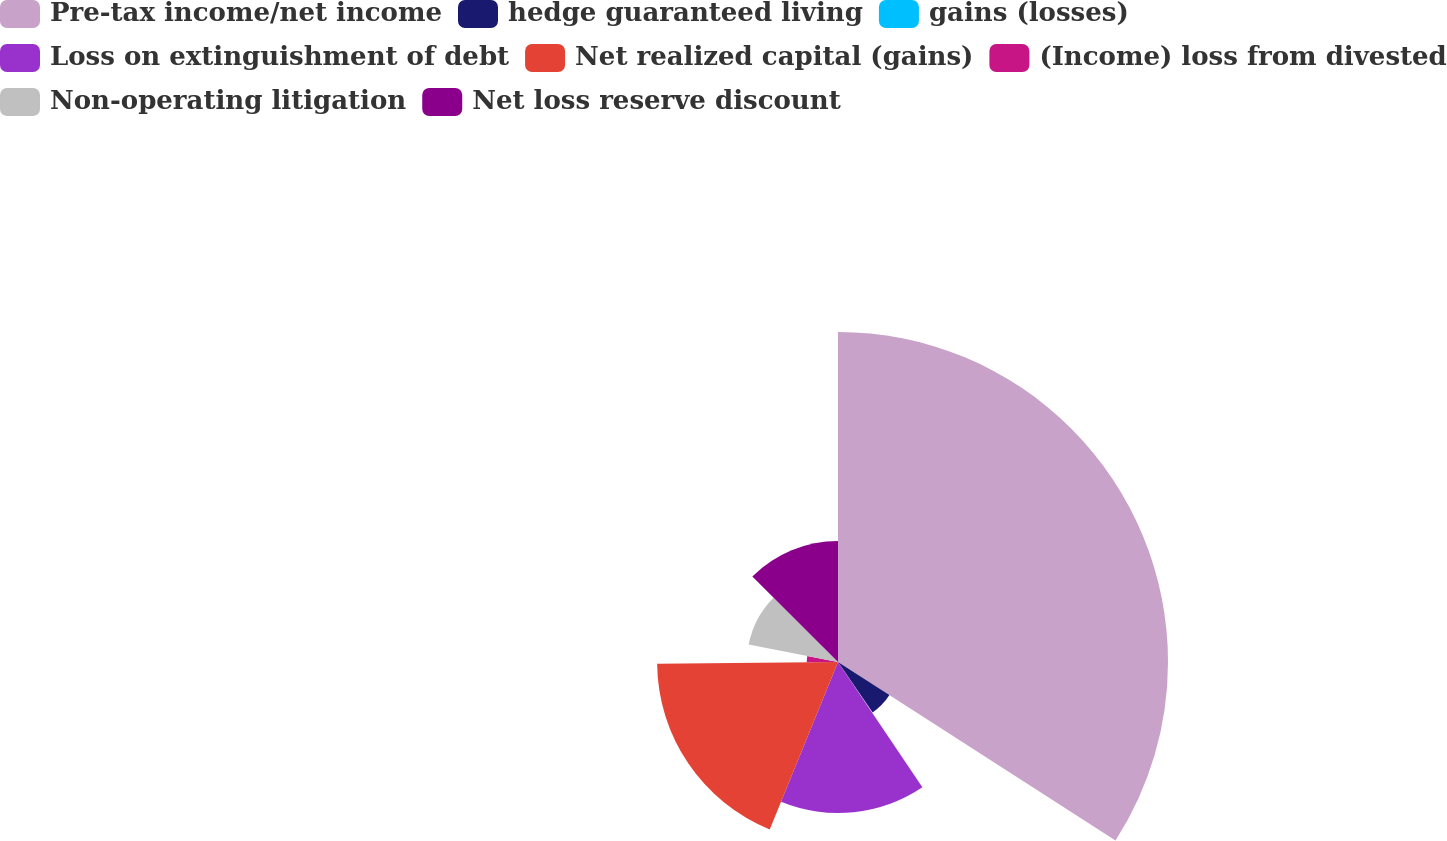<chart> <loc_0><loc_0><loc_500><loc_500><pie_chart><fcel>Pre-tax income/net income<fcel>hedge guaranteed living<fcel>gains (losses)<fcel>Loss on extinguishment of debt<fcel>Net realized capital (gains)<fcel>(Income) loss from divested<fcel>Non-operating litigation<fcel>Net loss reserve discount<nl><fcel>34.1%<fcel>6.32%<fcel>0.14%<fcel>15.6%<fcel>18.69%<fcel>3.23%<fcel>9.41%<fcel>12.51%<nl></chart> 